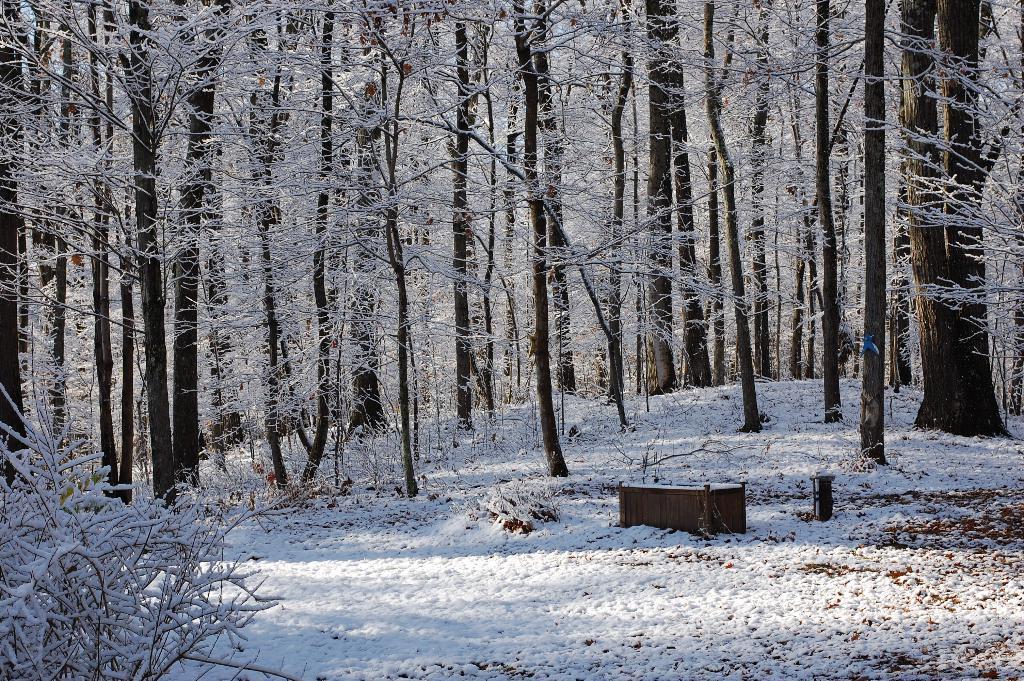Please provide a concise description of this image. In this image we can see trees and the ground covered with snow. 